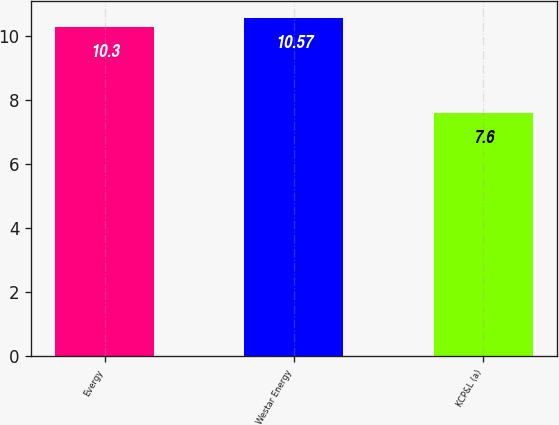<chart> <loc_0><loc_0><loc_500><loc_500><bar_chart><fcel>Evergy<fcel>Westar Energy<fcel>KCP&L (a)<nl><fcel>10.3<fcel>10.57<fcel>7.6<nl></chart> 